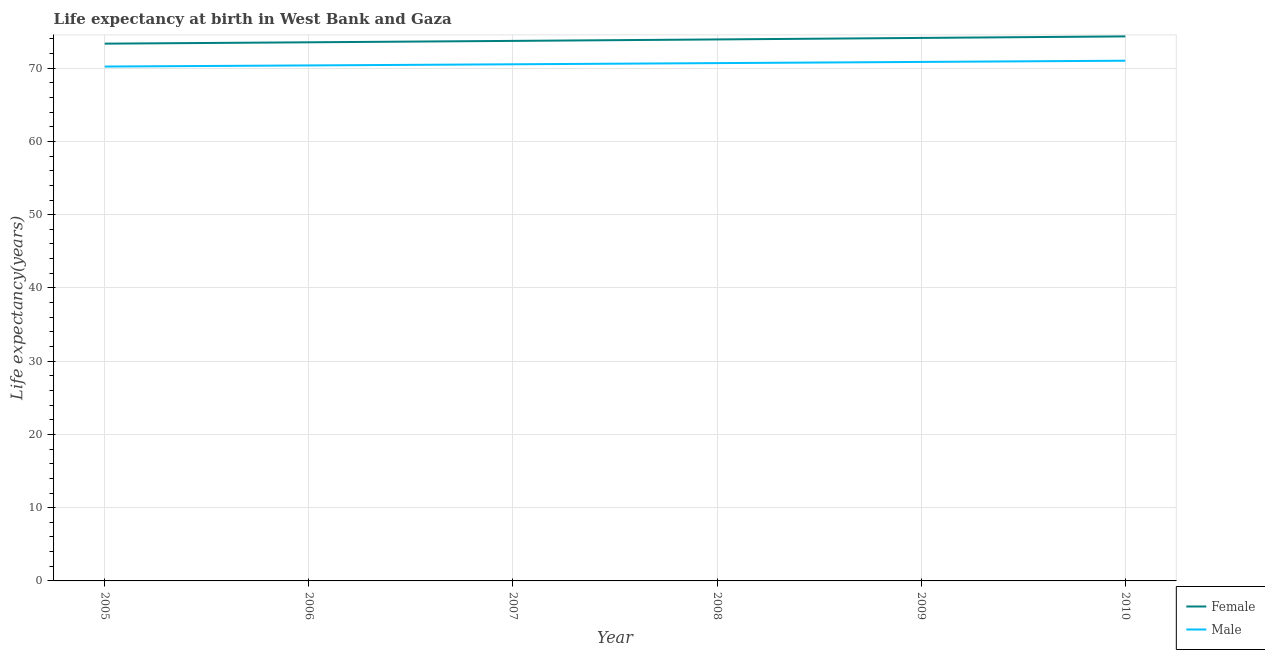How many different coloured lines are there?
Keep it short and to the point. 2. Does the line corresponding to life expectancy(male) intersect with the line corresponding to life expectancy(female)?
Your response must be concise. No. Is the number of lines equal to the number of legend labels?
Provide a short and direct response. Yes. What is the life expectancy(female) in 2005?
Make the answer very short. 73.35. Across all years, what is the maximum life expectancy(female)?
Your answer should be very brief. 74.34. Across all years, what is the minimum life expectancy(female)?
Your answer should be very brief. 73.35. In which year was the life expectancy(male) maximum?
Make the answer very short. 2010. In which year was the life expectancy(female) minimum?
Make the answer very short. 2005. What is the total life expectancy(male) in the graph?
Make the answer very short. 423.7. What is the difference between the life expectancy(female) in 2008 and that in 2009?
Provide a succinct answer. -0.2. What is the difference between the life expectancy(male) in 2007 and the life expectancy(female) in 2009?
Keep it short and to the point. -3.6. What is the average life expectancy(male) per year?
Provide a short and direct response. 70.62. In the year 2007, what is the difference between the life expectancy(male) and life expectancy(female)?
Offer a very short reply. -3.19. In how many years, is the life expectancy(female) greater than 24 years?
Make the answer very short. 6. What is the ratio of the life expectancy(female) in 2007 to that in 2009?
Ensure brevity in your answer.  0.99. Is the life expectancy(female) in 2005 less than that in 2009?
Keep it short and to the point. Yes. Is the difference between the life expectancy(female) in 2007 and 2008 greater than the difference between the life expectancy(male) in 2007 and 2008?
Provide a short and direct response. No. What is the difference between the highest and the second highest life expectancy(male)?
Offer a terse response. 0.16. What is the difference between the highest and the lowest life expectancy(male)?
Your answer should be very brief. 0.8. In how many years, is the life expectancy(female) greater than the average life expectancy(female) taken over all years?
Keep it short and to the point. 3. Is the sum of the life expectancy(female) in 2009 and 2010 greater than the maximum life expectancy(male) across all years?
Provide a short and direct response. Yes. Does the life expectancy(male) monotonically increase over the years?
Your answer should be very brief. Yes. Is the life expectancy(male) strictly greater than the life expectancy(female) over the years?
Offer a terse response. No. Are the values on the major ticks of Y-axis written in scientific E-notation?
Your answer should be compact. No. How many legend labels are there?
Offer a terse response. 2. What is the title of the graph?
Offer a terse response. Life expectancy at birth in West Bank and Gaza. Does "Old" appear as one of the legend labels in the graph?
Offer a very short reply. No. What is the label or title of the Y-axis?
Make the answer very short. Life expectancy(years). What is the Life expectancy(years) in Female in 2005?
Make the answer very short. 73.35. What is the Life expectancy(years) in Male in 2005?
Provide a succinct answer. 70.22. What is the Life expectancy(years) in Female in 2006?
Offer a very short reply. 73.53. What is the Life expectancy(years) of Male in 2006?
Your answer should be very brief. 70.38. What is the Life expectancy(years) in Female in 2007?
Provide a short and direct response. 73.73. What is the Life expectancy(years) of Male in 2007?
Give a very brief answer. 70.53. What is the Life expectancy(years) in Female in 2008?
Give a very brief answer. 73.93. What is the Life expectancy(years) of Male in 2008?
Offer a terse response. 70.69. What is the Life expectancy(years) in Female in 2009?
Provide a short and direct response. 74.13. What is the Life expectancy(years) in Male in 2009?
Provide a short and direct response. 70.86. What is the Life expectancy(years) in Female in 2010?
Keep it short and to the point. 74.34. What is the Life expectancy(years) of Male in 2010?
Make the answer very short. 71.02. Across all years, what is the maximum Life expectancy(years) in Female?
Offer a very short reply. 74.34. Across all years, what is the maximum Life expectancy(years) of Male?
Your answer should be very brief. 71.02. Across all years, what is the minimum Life expectancy(years) in Female?
Give a very brief answer. 73.35. Across all years, what is the minimum Life expectancy(years) in Male?
Provide a short and direct response. 70.22. What is the total Life expectancy(years) in Female in the graph?
Your answer should be compact. 443.01. What is the total Life expectancy(years) in Male in the graph?
Ensure brevity in your answer.  423.7. What is the difference between the Life expectancy(years) in Female in 2005 and that in 2006?
Your answer should be compact. -0.18. What is the difference between the Life expectancy(years) in Male in 2005 and that in 2006?
Ensure brevity in your answer.  -0.15. What is the difference between the Life expectancy(years) in Female in 2005 and that in 2007?
Provide a short and direct response. -0.38. What is the difference between the Life expectancy(years) of Male in 2005 and that in 2007?
Your answer should be compact. -0.31. What is the difference between the Life expectancy(years) in Female in 2005 and that in 2008?
Provide a short and direct response. -0.58. What is the difference between the Life expectancy(years) of Male in 2005 and that in 2008?
Keep it short and to the point. -0.47. What is the difference between the Life expectancy(years) in Female in 2005 and that in 2009?
Your response must be concise. -0.78. What is the difference between the Life expectancy(years) of Male in 2005 and that in 2009?
Give a very brief answer. -0.63. What is the difference between the Life expectancy(years) in Female in 2005 and that in 2010?
Make the answer very short. -0.99. What is the difference between the Life expectancy(years) of Male in 2005 and that in 2010?
Provide a succinct answer. -0.8. What is the difference between the Life expectancy(years) of Female in 2006 and that in 2007?
Your answer should be compact. -0.19. What is the difference between the Life expectancy(years) of Male in 2006 and that in 2007?
Provide a succinct answer. -0.16. What is the difference between the Life expectancy(years) in Female in 2006 and that in 2008?
Offer a terse response. -0.39. What is the difference between the Life expectancy(years) in Male in 2006 and that in 2008?
Your response must be concise. -0.32. What is the difference between the Life expectancy(years) of Female in 2006 and that in 2009?
Keep it short and to the point. -0.6. What is the difference between the Life expectancy(years) of Male in 2006 and that in 2009?
Provide a short and direct response. -0.48. What is the difference between the Life expectancy(years) of Female in 2006 and that in 2010?
Offer a terse response. -0.81. What is the difference between the Life expectancy(years) in Male in 2006 and that in 2010?
Your answer should be very brief. -0.64. What is the difference between the Life expectancy(years) in Female in 2007 and that in 2008?
Provide a succinct answer. -0.2. What is the difference between the Life expectancy(years) in Male in 2007 and that in 2008?
Provide a succinct answer. -0.16. What is the difference between the Life expectancy(years) of Female in 2007 and that in 2009?
Offer a very short reply. -0.4. What is the difference between the Life expectancy(years) in Male in 2007 and that in 2009?
Provide a short and direct response. -0.32. What is the difference between the Life expectancy(years) in Female in 2007 and that in 2010?
Make the answer very short. -0.61. What is the difference between the Life expectancy(years) in Male in 2007 and that in 2010?
Provide a short and direct response. -0.49. What is the difference between the Life expectancy(years) of Female in 2008 and that in 2009?
Ensure brevity in your answer.  -0.2. What is the difference between the Life expectancy(years) in Male in 2008 and that in 2009?
Your answer should be compact. -0.16. What is the difference between the Life expectancy(years) in Female in 2008 and that in 2010?
Ensure brevity in your answer.  -0.42. What is the difference between the Life expectancy(years) of Male in 2008 and that in 2010?
Keep it short and to the point. -0.33. What is the difference between the Life expectancy(years) in Female in 2009 and that in 2010?
Make the answer very short. -0.21. What is the difference between the Life expectancy(years) in Male in 2009 and that in 2010?
Your answer should be compact. -0.17. What is the difference between the Life expectancy(years) in Female in 2005 and the Life expectancy(years) in Male in 2006?
Keep it short and to the point. 2.97. What is the difference between the Life expectancy(years) of Female in 2005 and the Life expectancy(years) of Male in 2007?
Provide a succinct answer. 2.82. What is the difference between the Life expectancy(years) of Female in 2005 and the Life expectancy(years) of Male in 2008?
Make the answer very short. 2.66. What is the difference between the Life expectancy(years) of Female in 2005 and the Life expectancy(years) of Male in 2009?
Your answer should be very brief. 2.5. What is the difference between the Life expectancy(years) in Female in 2005 and the Life expectancy(years) in Male in 2010?
Offer a very short reply. 2.33. What is the difference between the Life expectancy(years) in Female in 2006 and the Life expectancy(years) in Male in 2008?
Give a very brief answer. 2.84. What is the difference between the Life expectancy(years) of Female in 2006 and the Life expectancy(years) of Male in 2009?
Offer a very short reply. 2.68. What is the difference between the Life expectancy(years) in Female in 2006 and the Life expectancy(years) in Male in 2010?
Provide a short and direct response. 2.51. What is the difference between the Life expectancy(years) of Female in 2007 and the Life expectancy(years) of Male in 2008?
Provide a succinct answer. 3.03. What is the difference between the Life expectancy(years) of Female in 2007 and the Life expectancy(years) of Male in 2009?
Your response must be concise. 2.87. What is the difference between the Life expectancy(years) of Female in 2007 and the Life expectancy(years) of Male in 2010?
Your answer should be compact. 2.71. What is the difference between the Life expectancy(years) in Female in 2008 and the Life expectancy(years) in Male in 2009?
Make the answer very short. 3.07. What is the difference between the Life expectancy(years) in Female in 2008 and the Life expectancy(years) in Male in 2010?
Your answer should be compact. 2.91. What is the difference between the Life expectancy(years) in Female in 2009 and the Life expectancy(years) in Male in 2010?
Your answer should be compact. 3.11. What is the average Life expectancy(years) in Female per year?
Ensure brevity in your answer.  73.83. What is the average Life expectancy(years) in Male per year?
Give a very brief answer. 70.62. In the year 2005, what is the difference between the Life expectancy(years) of Female and Life expectancy(years) of Male?
Give a very brief answer. 3.13. In the year 2006, what is the difference between the Life expectancy(years) in Female and Life expectancy(years) in Male?
Your answer should be very brief. 3.16. In the year 2007, what is the difference between the Life expectancy(years) of Female and Life expectancy(years) of Male?
Keep it short and to the point. 3.19. In the year 2008, what is the difference between the Life expectancy(years) in Female and Life expectancy(years) in Male?
Your answer should be very brief. 3.23. In the year 2009, what is the difference between the Life expectancy(years) of Female and Life expectancy(years) of Male?
Offer a terse response. 3.28. In the year 2010, what is the difference between the Life expectancy(years) in Female and Life expectancy(years) in Male?
Your answer should be compact. 3.32. What is the ratio of the Life expectancy(years) in Male in 2005 to that in 2006?
Ensure brevity in your answer.  1. What is the ratio of the Life expectancy(years) in Male in 2005 to that in 2007?
Offer a very short reply. 1. What is the ratio of the Life expectancy(years) of Male in 2005 to that in 2008?
Make the answer very short. 0.99. What is the ratio of the Life expectancy(years) in Female in 2005 to that in 2009?
Your answer should be compact. 0.99. What is the ratio of the Life expectancy(years) of Male in 2005 to that in 2009?
Offer a very short reply. 0.99. What is the ratio of the Life expectancy(years) in Female in 2005 to that in 2010?
Give a very brief answer. 0.99. What is the ratio of the Life expectancy(years) of Male in 2005 to that in 2010?
Your answer should be compact. 0.99. What is the ratio of the Life expectancy(years) of Male in 2006 to that in 2007?
Provide a succinct answer. 1. What is the ratio of the Life expectancy(years) in Female in 2006 to that in 2008?
Make the answer very short. 0.99. What is the ratio of the Life expectancy(years) in Male in 2006 to that in 2008?
Offer a terse response. 1. What is the ratio of the Life expectancy(years) in Female in 2006 to that in 2009?
Offer a very short reply. 0.99. What is the ratio of the Life expectancy(years) in Male in 2006 to that in 2009?
Your response must be concise. 0.99. What is the ratio of the Life expectancy(years) of Female in 2006 to that in 2010?
Your response must be concise. 0.99. What is the ratio of the Life expectancy(years) in Male in 2006 to that in 2010?
Your answer should be compact. 0.99. What is the ratio of the Life expectancy(years) in Female in 2007 to that in 2008?
Provide a succinct answer. 1. What is the ratio of the Life expectancy(years) of Male in 2007 to that in 2008?
Provide a short and direct response. 1. What is the ratio of the Life expectancy(years) of Female in 2007 to that in 2009?
Your response must be concise. 0.99. What is the ratio of the Life expectancy(years) of Female in 2007 to that in 2010?
Provide a succinct answer. 0.99. What is the ratio of the Life expectancy(years) in Male in 2007 to that in 2010?
Keep it short and to the point. 0.99. What is the ratio of the Life expectancy(years) of Female in 2008 to that in 2009?
Make the answer very short. 1. What is the ratio of the Life expectancy(years) in Male in 2008 to that in 2009?
Provide a short and direct response. 1. What is the ratio of the Life expectancy(years) in Female in 2008 to that in 2010?
Ensure brevity in your answer.  0.99. What is the ratio of the Life expectancy(years) in Male in 2008 to that in 2010?
Make the answer very short. 1. What is the ratio of the Life expectancy(years) in Female in 2009 to that in 2010?
Give a very brief answer. 1. What is the ratio of the Life expectancy(years) in Male in 2009 to that in 2010?
Ensure brevity in your answer.  1. What is the difference between the highest and the second highest Life expectancy(years) in Female?
Provide a succinct answer. 0.21. What is the difference between the highest and the second highest Life expectancy(years) in Male?
Provide a short and direct response. 0.17. What is the difference between the highest and the lowest Life expectancy(years) in Female?
Provide a short and direct response. 0.99. What is the difference between the highest and the lowest Life expectancy(years) of Male?
Offer a terse response. 0.8. 